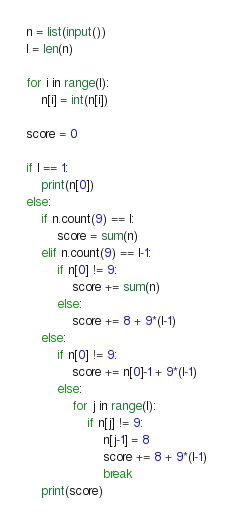<code> <loc_0><loc_0><loc_500><loc_500><_Python_>n = list(input())
l = len(n)

for i in range(l):
    n[i] = int(n[i])

score = 0

if l == 1:
    print(n[0])
else:
    if n.count(9) == l:
        score = sum(n)
    elif n.count(9) == l-1:
        if n[0] != 9:
            score += sum(n)
        else:
            score += 8 + 9*(l-1)
    else:
        if n[0] != 9:
            score += n[0]-1 + 9*(l-1)
        else:
            for j in range(l):
                if n[j] != 9:
                    n[j-1] = 8
                    score += 8 + 9*(l-1)
                    break
    print(score)</code> 